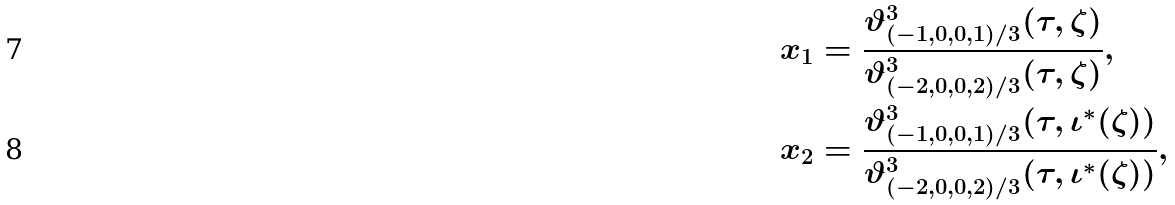<formula> <loc_0><loc_0><loc_500><loc_500>x _ { 1 } & = \frac { \vartheta _ { ( - 1 , 0 , 0 , 1 ) / 3 } ^ { 3 } ( \tau , \zeta ) } { \vartheta _ { ( - 2 , 0 , 0 , 2 ) / 3 } ^ { 3 } ( \tau , \zeta ) } , \\ x _ { 2 } & = \frac { \vartheta _ { ( - 1 , 0 , 0 , 1 ) / 3 } ^ { 3 } ( \tau , \iota ^ { * } ( \zeta ) ) } { \vartheta _ { ( - 2 , 0 , 0 , 2 ) / 3 } ^ { 3 } ( \tau , \iota ^ { * } ( \zeta ) ) } ,</formula> 